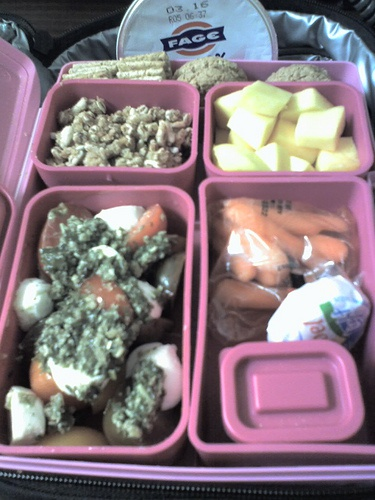Describe the objects in this image and their specific colors. I can see apple in black, beige, khaki, and tan tones, broccoli in black, darkgray, gray, and ivory tones, broccoli in black, gray, and darkgray tones, carrot in black, salmon, and gray tones, and broccoli in black, gray, and darkgray tones in this image. 